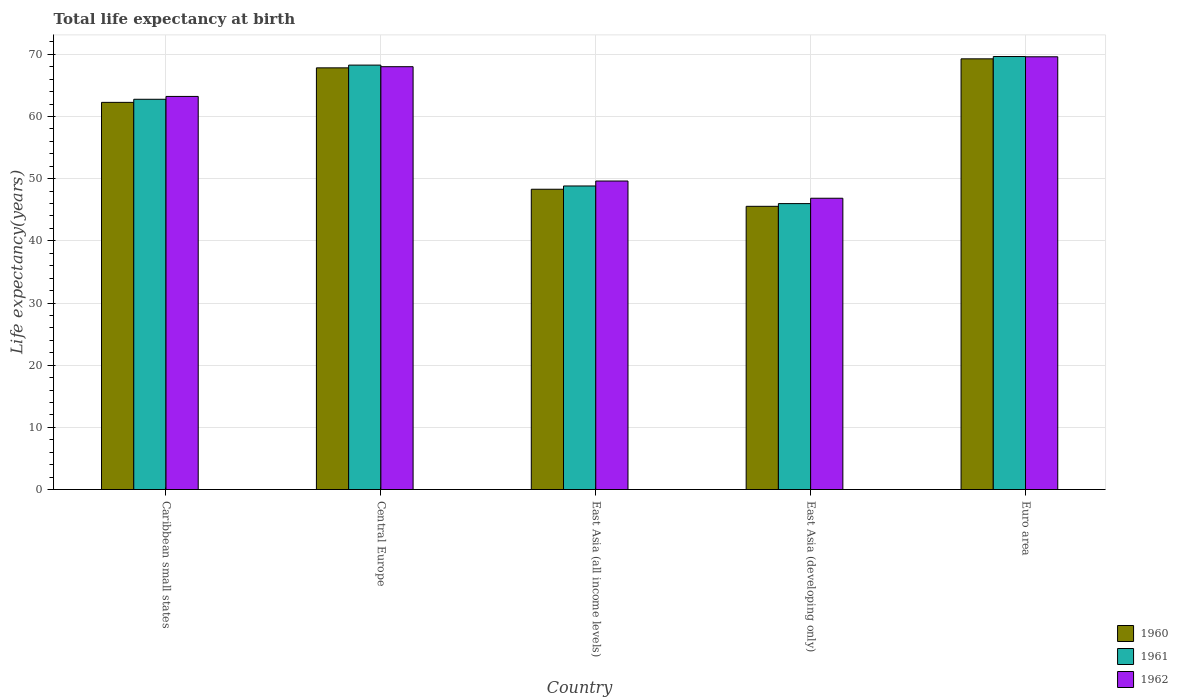Are the number of bars on each tick of the X-axis equal?
Provide a succinct answer. Yes. How many bars are there on the 5th tick from the left?
Offer a terse response. 3. How many bars are there on the 5th tick from the right?
Keep it short and to the point. 3. What is the label of the 3rd group of bars from the left?
Your answer should be compact. East Asia (all income levels). What is the life expectancy at birth in in 1962 in East Asia (developing only)?
Your response must be concise. 46.85. Across all countries, what is the maximum life expectancy at birth in in 1962?
Give a very brief answer. 69.6. Across all countries, what is the minimum life expectancy at birth in in 1960?
Ensure brevity in your answer.  45.55. In which country was the life expectancy at birth in in 1960 minimum?
Make the answer very short. East Asia (developing only). What is the total life expectancy at birth in in 1960 in the graph?
Your response must be concise. 293.22. What is the difference between the life expectancy at birth in in 1962 in East Asia (developing only) and that in Euro area?
Your answer should be compact. -22.75. What is the difference between the life expectancy at birth in in 1961 in Central Europe and the life expectancy at birth in in 1962 in Euro area?
Your answer should be very brief. -1.34. What is the average life expectancy at birth in in 1961 per country?
Provide a succinct answer. 59.1. What is the difference between the life expectancy at birth in of/in 1960 and life expectancy at birth in of/in 1961 in Caribbean small states?
Provide a short and direct response. -0.5. In how many countries, is the life expectancy at birth in in 1961 greater than 4 years?
Keep it short and to the point. 5. What is the ratio of the life expectancy at birth in in 1961 in Caribbean small states to that in Euro area?
Provide a short and direct response. 0.9. Is the life expectancy at birth in in 1960 in Caribbean small states less than that in East Asia (developing only)?
Your response must be concise. No. What is the difference between the highest and the second highest life expectancy at birth in in 1961?
Keep it short and to the point. -1.38. What is the difference between the highest and the lowest life expectancy at birth in in 1962?
Offer a very short reply. 22.75. What does the 3rd bar from the right in East Asia (all income levels) represents?
Your answer should be compact. 1960. Is it the case that in every country, the sum of the life expectancy at birth in in 1961 and life expectancy at birth in in 1960 is greater than the life expectancy at birth in in 1962?
Provide a succinct answer. Yes. How many bars are there?
Provide a short and direct response. 15. Are all the bars in the graph horizontal?
Your answer should be very brief. No. Are the values on the major ticks of Y-axis written in scientific E-notation?
Your answer should be very brief. No. Does the graph contain any zero values?
Offer a terse response. No. Where does the legend appear in the graph?
Provide a succinct answer. Bottom right. How are the legend labels stacked?
Ensure brevity in your answer.  Vertical. What is the title of the graph?
Offer a terse response. Total life expectancy at birth. What is the label or title of the Y-axis?
Ensure brevity in your answer.  Life expectancy(years). What is the Life expectancy(years) in 1960 in Caribbean small states?
Your answer should be compact. 62.27. What is the Life expectancy(years) in 1961 in Caribbean small states?
Offer a very short reply. 62.77. What is the Life expectancy(years) in 1962 in Caribbean small states?
Make the answer very short. 63.23. What is the Life expectancy(years) in 1960 in Central Europe?
Give a very brief answer. 67.82. What is the Life expectancy(years) of 1961 in Central Europe?
Your response must be concise. 68.26. What is the Life expectancy(years) of 1962 in Central Europe?
Provide a short and direct response. 68.01. What is the Life expectancy(years) of 1960 in East Asia (all income levels)?
Give a very brief answer. 48.3. What is the Life expectancy(years) of 1961 in East Asia (all income levels)?
Ensure brevity in your answer.  48.82. What is the Life expectancy(years) in 1962 in East Asia (all income levels)?
Keep it short and to the point. 49.62. What is the Life expectancy(years) of 1960 in East Asia (developing only)?
Give a very brief answer. 45.55. What is the Life expectancy(years) of 1961 in East Asia (developing only)?
Provide a succinct answer. 45.99. What is the Life expectancy(years) of 1962 in East Asia (developing only)?
Give a very brief answer. 46.85. What is the Life expectancy(years) in 1960 in Euro area?
Make the answer very short. 69.27. What is the Life expectancy(years) in 1961 in Euro area?
Offer a terse response. 69.64. What is the Life expectancy(years) of 1962 in Euro area?
Offer a terse response. 69.6. Across all countries, what is the maximum Life expectancy(years) of 1960?
Keep it short and to the point. 69.27. Across all countries, what is the maximum Life expectancy(years) of 1961?
Keep it short and to the point. 69.64. Across all countries, what is the maximum Life expectancy(years) of 1962?
Your answer should be compact. 69.6. Across all countries, what is the minimum Life expectancy(years) in 1960?
Provide a short and direct response. 45.55. Across all countries, what is the minimum Life expectancy(years) in 1961?
Provide a short and direct response. 45.99. Across all countries, what is the minimum Life expectancy(years) in 1962?
Keep it short and to the point. 46.85. What is the total Life expectancy(years) in 1960 in the graph?
Offer a terse response. 293.22. What is the total Life expectancy(years) in 1961 in the graph?
Ensure brevity in your answer.  295.49. What is the total Life expectancy(years) of 1962 in the graph?
Offer a very short reply. 297.31. What is the difference between the Life expectancy(years) of 1960 in Caribbean small states and that in Central Europe?
Your answer should be compact. -5.55. What is the difference between the Life expectancy(years) in 1961 in Caribbean small states and that in Central Europe?
Make the answer very short. -5.49. What is the difference between the Life expectancy(years) in 1962 in Caribbean small states and that in Central Europe?
Offer a very short reply. -4.78. What is the difference between the Life expectancy(years) of 1960 in Caribbean small states and that in East Asia (all income levels)?
Your response must be concise. 13.97. What is the difference between the Life expectancy(years) of 1961 in Caribbean small states and that in East Asia (all income levels)?
Give a very brief answer. 13.95. What is the difference between the Life expectancy(years) of 1962 in Caribbean small states and that in East Asia (all income levels)?
Give a very brief answer. 13.61. What is the difference between the Life expectancy(years) of 1960 in Caribbean small states and that in East Asia (developing only)?
Your answer should be compact. 16.72. What is the difference between the Life expectancy(years) in 1961 in Caribbean small states and that in East Asia (developing only)?
Your response must be concise. 16.78. What is the difference between the Life expectancy(years) of 1962 in Caribbean small states and that in East Asia (developing only)?
Your answer should be compact. 16.37. What is the difference between the Life expectancy(years) of 1960 in Caribbean small states and that in Euro area?
Make the answer very short. -7. What is the difference between the Life expectancy(years) in 1961 in Caribbean small states and that in Euro area?
Keep it short and to the point. -6.88. What is the difference between the Life expectancy(years) of 1962 in Caribbean small states and that in Euro area?
Your answer should be very brief. -6.38. What is the difference between the Life expectancy(years) of 1960 in Central Europe and that in East Asia (all income levels)?
Your answer should be compact. 19.53. What is the difference between the Life expectancy(years) in 1961 in Central Europe and that in East Asia (all income levels)?
Offer a very short reply. 19.44. What is the difference between the Life expectancy(years) in 1962 in Central Europe and that in East Asia (all income levels)?
Offer a terse response. 18.39. What is the difference between the Life expectancy(years) of 1960 in Central Europe and that in East Asia (developing only)?
Your response must be concise. 22.27. What is the difference between the Life expectancy(years) of 1961 in Central Europe and that in East Asia (developing only)?
Offer a very short reply. 22.28. What is the difference between the Life expectancy(years) in 1962 in Central Europe and that in East Asia (developing only)?
Offer a very short reply. 21.16. What is the difference between the Life expectancy(years) of 1960 in Central Europe and that in Euro area?
Provide a short and direct response. -1.45. What is the difference between the Life expectancy(years) in 1961 in Central Europe and that in Euro area?
Ensure brevity in your answer.  -1.38. What is the difference between the Life expectancy(years) of 1962 in Central Europe and that in Euro area?
Offer a very short reply. -1.59. What is the difference between the Life expectancy(years) of 1960 in East Asia (all income levels) and that in East Asia (developing only)?
Provide a succinct answer. 2.75. What is the difference between the Life expectancy(years) of 1961 in East Asia (all income levels) and that in East Asia (developing only)?
Make the answer very short. 2.84. What is the difference between the Life expectancy(years) of 1962 in East Asia (all income levels) and that in East Asia (developing only)?
Provide a succinct answer. 2.77. What is the difference between the Life expectancy(years) in 1960 in East Asia (all income levels) and that in Euro area?
Your answer should be compact. -20.98. What is the difference between the Life expectancy(years) in 1961 in East Asia (all income levels) and that in Euro area?
Keep it short and to the point. -20.82. What is the difference between the Life expectancy(years) in 1962 in East Asia (all income levels) and that in Euro area?
Your response must be concise. -19.98. What is the difference between the Life expectancy(years) in 1960 in East Asia (developing only) and that in Euro area?
Make the answer very short. -23.72. What is the difference between the Life expectancy(years) in 1961 in East Asia (developing only) and that in Euro area?
Provide a succinct answer. -23.66. What is the difference between the Life expectancy(years) in 1962 in East Asia (developing only) and that in Euro area?
Provide a succinct answer. -22.75. What is the difference between the Life expectancy(years) in 1960 in Caribbean small states and the Life expectancy(years) in 1961 in Central Europe?
Provide a succinct answer. -5.99. What is the difference between the Life expectancy(years) of 1960 in Caribbean small states and the Life expectancy(years) of 1962 in Central Europe?
Provide a short and direct response. -5.74. What is the difference between the Life expectancy(years) of 1961 in Caribbean small states and the Life expectancy(years) of 1962 in Central Europe?
Keep it short and to the point. -5.24. What is the difference between the Life expectancy(years) in 1960 in Caribbean small states and the Life expectancy(years) in 1961 in East Asia (all income levels)?
Your answer should be compact. 13.45. What is the difference between the Life expectancy(years) in 1960 in Caribbean small states and the Life expectancy(years) in 1962 in East Asia (all income levels)?
Provide a succinct answer. 12.65. What is the difference between the Life expectancy(years) in 1961 in Caribbean small states and the Life expectancy(years) in 1962 in East Asia (all income levels)?
Give a very brief answer. 13.15. What is the difference between the Life expectancy(years) in 1960 in Caribbean small states and the Life expectancy(years) in 1961 in East Asia (developing only)?
Keep it short and to the point. 16.28. What is the difference between the Life expectancy(years) of 1960 in Caribbean small states and the Life expectancy(years) of 1962 in East Asia (developing only)?
Offer a very short reply. 15.42. What is the difference between the Life expectancy(years) of 1961 in Caribbean small states and the Life expectancy(years) of 1962 in East Asia (developing only)?
Offer a very short reply. 15.92. What is the difference between the Life expectancy(years) in 1960 in Caribbean small states and the Life expectancy(years) in 1961 in Euro area?
Your answer should be very brief. -7.37. What is the difference between the Life expectancy(years) in 1960 in Caribbean small states and the Life expectancy(years) in 1962 in Euro area?
Make the answer very short. -7.33. What is the difference between the Life expectancy(years) of 1961 in Caribbean small states and the Life expectancy(years) of 1962 in Euro area?
Your response must be concise. -6.83. What is the difference between the Life expectancy(years) of 1960 in Central Europe and the Life expectancy(years) of 1961 in East Asia (all income levels)?
Provide a short and direct response. 19. What is the difference between the Life expectancy(years) of 1960 in Central Europe and the Life expectancy(years) of 1962 in East Asia (all income levels)?
Provide a succinct answer. 18.2. What is the difference between the Life expectancy(years) of 1961 in Central Europe and the Life expectancy(years) of 1962 in East Asia (all income levels)?
Provide a succinct answer. 18.64. What is the difference between the Life expectancy(years) in 1960 in Central Europe and the Life expectancy(years) in 1961 in East Asia (developing only)?
Ensure brevity in your answer.  21.84. What is the difference between the Life expectancy(years) in 1960 in Central Europe and the Life expectancy(years) in 1962 in East Asia (developing only)?
Offer a terse response. 20.97. What is the difference between the Life expectancy(years) of 1961 in Central Europe and the Life expectancy(years) of 1962 in East Asia (developing only)?
Ensure brevity in your answer.  21.41. What is the difference between the Life expectancy(years) of 1960 in Central Europe and the Life expectancy(years) of 1961 in Euro area?
Keep it short and to the point. -1.82. What is the difference between the Life expectancy(years) of 1960 in Central Europe and the Life expectancy(years) of 1962 in Euro area?
Ensure brevity in your answer.  -1.78. What is the difference between the Life expectancy(years) in 1961 in Central Europe and the Life expectancy(years) in 1962 in Euro area?
Your response must be concise. -1.34. What is the difference between the Life expectancy(years) of 1960 in East Asia (all income levels) and the Life expectancy(years) of 1961 in East Asia (developing only)?
Provide a succinct answer. 2.31. What is the difference between the Life expectancy(years) in 1960 in East Asia (all income levels) and the Life expectancy(years) in 1962 in East Asia (developing only)?
Your response must be concise. 1.45. What is the difference between the Life expectancy(years) of 1961 in East Asia (all income levels) and the Life expectancy(years) of 1962 in East Asia (developing only)?
Make the answer very short. 1.97. What is the difference between the Life expectancy(years) of 1960 in East Asia (all income levels) and the Life expectancy(years) of 1961 in Euro area?
Your answer should be compact. -21.35. What is the difference between the Life expectancy(years) of 1960 in East Asia (all income levels) and the Life expectancy(years) of 1962 in Euro area?
Make the answer very short. -21.3. What is the difference between the Life expectancy(years) in 1961 in East Asia (all income levels) and the Life expectancy(years) in 1962 in Euro area?
Offer a very short reply. -20.78. What is the difference between the Life expectancy(years) in 1960 in East Asia (developing only) and the Life expectancy(years) in 1961 in Euro area?
Keep it short and to the point. -24.09. What is the difference between the Life expectancy(years) in 1960 in East Asia (developing only) and the Life expectancy(years) in 1962 in Euro area?
Give a very brief answer. -24.05. What is the difference between the Life expectancy(years) of 1961 in East Asia (developing only) and the Life expectancy(years) of 1962 in Euro area?
Ensure brevity in your answer.  -23.62. What is the average Life expectancy(years) of 1960 per country?
Provide a short and direct response. 58.64. What is the average Life expectancy(years) of 1961 per country?
Keep it short and to the point. 59.1. What is the average Life expectancy(years) in 1962 per country?
Give a very brief answer. 59.46. What is the difference between the Life expectancy(years) in 1960 and Life expectancy(years) in 1961 in Caribbean small states?
Offer a terse response. -0.5. What is the difference between the Life expectancy(years) of 1960 and Life expectancy(years) of 1962 in Caribbean small states?
Your response must be concise. -0.95. What is the difference between the Life expectancy(years) of 1961 and Life expectancy(years) of 1962 in Caribbean small states?
Provide a short and direct response. -0.46. What is the difference between the Life expectancy(years) of 1960 and Life expectancy(years) of 1961 in Central Europe?
Provide a short and direct response. -0.44. What is the difference between the Life expectancy(years) of 1960 and Life expectancy(years) of 1962 in Central Europe?
Provide a succinct answer. -0.18. What is the difference between the Life expectancy(years) of 1961 and Life expectancy(years) of 1962 in Central Europe?
Offer a terse response. 0.26. What is the difference between the Life expectancy(years) of 1960 and Life expectancy(years) of 1961 in East Asia (all income levels)?
Keep it short and to the point. -0.53. What is the difference between the Life expectancy(years) in 1960 and Life expectancy(years) in 1962 in East Asia (all income levels)?
Ensure brevity in your answer.  -1.32. What is the difference between the Life expectancy(years) in 1961 and Life expectancy(years) in 1962 in East Asia (all income levels)?
Provide a short and direct response. -0.8. What is the difference between the Life expectancy(years) of 1960 and Life expectancy(years) of 1961 in East Asia (developing only)?
Your answer should be very brief. -0.44. What is the difference between the Life expectancy(years) in 1960 and Life expectancy(years) in 1962 in East Asia (developing only)?
Offer a very short reply. -1.3. What is the difference between the Life expectancy(years) of 1961 and Life expectancy(years) of 1962 in East Asia (developing only)?
Ensure brevity in your answer.  -0.86. What is the difference between the Life expectancy(years) in 1960 and Life expectancy(years) in 1961 in Euro area?
Offer a terse response. -0.37. What is the difference between the Life expectancy(years) of 1960 and Life expectancy(years) of 1962 in Euro area?
Offer a very short reply. -0.33. What is the difference between the Life expectancy(years) in 1961 and Life expectancy(years) in 1962 in Euro area?
Ensure brevity in your answer.  0.04. What is the ratio of the Life expectancy(years) in 1960 in Caribbean small states to that in Central Europe?
Ensure brevity in your answer.  0.92. What is the ratio of the Life expectancy(years) of 1961 in Caribbean small states to that in Central Europe?
Provide a short and direct response. 0.92. What is the ratio of the Life expectancy(years) of 1962 in Caribbean small states to that in Central Europe?
Offer a very short reply. 0.93. What is the ratio of the Life expectancy(years) of 1960 in Caribbean small states to that in East Asia (all income levels)?
Provide a succinct answer. 1.29. What is the ratio of the Life expectancy(years) in 1961 in Caribbean small states to that in East Asia (all income levels)?
Offer a very short reply. 1.29. What is the ratio of the Life expectancy(years) in 1962 in Caribbean small states to that in East Asia (all income levels)?
Keep it short and to the point. 1.27. What is the ratio of the Life expectancy(years) in 1960 in Caribbean small states to that in East Asia (developing only)?
Provide a succinct answer. 1.37. What is the ratio of the Life expectancy(years) of 1961 in Caribbean small states to that in East Asia (developing only)?
Provide a short and direct response. 1.36. What is the ratio of the Life expectancy(years) in 1962 in Caribbean small states to that in East Asia (developing only)?
Provide a succinct answer. 1.35. What is the ratio of the Life expectancy(years) of 1960 in Caribbean small states to that in Euro area?
Make the answer very short. 0.9. What is the ratio of the Life expectancy(years) of 1961 in Caribbean small states to that in Euro area?
Ensure brevity in your answer.  0.9. What is the ratio of the Life expectancy(years) of 1962 in Caribbean small states to that in Euro area?
Make the answer very short. 0.91. What is the ratio of the Life expectancy(years) of 1960 in Central Europe to that in East Asia (all income levels)?
Offer a very short reply. 1.4. What is the ratio of the Life expectancy(years) of 1961 in Central Europe to that in East Asia (all income levels)?
Your answer should be very brief. 1.4. What is the ratio of the Life expectancy(years) in 1962 in Central Europe to that in East Asia (all income levels)?
Offer a terse response. 1.37. What is the ratio of the Life expectancy(years) in 1960 in Central Europe to that in East Asia (developing only)?
Provide a short and direct response. 1.49. What is the ratio of the Life expectancy(years) in 1961 in Central Europe to that in East Asia (developing only)?
Give a very brief answer. 1.48. What is the ratio of the Life expectancy(years) in 1962 in Central Europe to that in East Asia (developing only)?
Keep it short and to the point. 1.45. What is the ratio of the Life expectancy(years) in 1960 in Central Europe to that in Euro area?
Ensure brevity in your answer.  0.98. What is the ratio of the Life expectancy(years) of 1961 in Central Europe to that in Euro area?
Provide a succinct answer. 0.98. What is the ratio of the Life expectancy(years) in 1962 in Central Europe to that in Euro area?
Provide a succinct answer. 0.98. What is the ratio of the Life expectancy(years) of 1960 in East Asia (all income levels) to that in East Asia (developing only)?
Provide a succinct answer. 1.06. What is the ratio of the Life expectancy(years) in 1961 in East Asia (all income levels) to that in East Asia (developing only)?
Offer a terse response. 1.06. What is the ratio of the Life expectancy(years) of 1962 in East Asia (all income levels) to that in East Asia (developing only)?
Provide a succinct answer. 1.06. What is the ratio of the Life expectancy(years) of 1960 in East Asia (all income levels) to that in Euro area?
Provide a succinct answer. 0.7. What is the ratio of the Life expectancy(years) of 1961 in East Asia (all income levels) to that in Euro area?
Provide a short and direct response. 0.7. What is the ratio of the Life expectancy(years) of 1962 in East Asia (all income levels) to that in Euro area?
Give a very brief answer. 0.71. What is the ratio of the Life expectancy(years) of 1960 in East Asia (developing only) to that in Euro area?
Your answer should be very brief. 0.66. What is the ratio of the Life expectancy(years) in 1961 in East Asia (developing only) to that in Euro area?
Provide a succinct answer. 0.66. What is the ratio of the Life expectancy(years) in 1962 in East Asia (developing only) to that in Euro area?
Keep it short and to the point. 0.67. What is the difference between the highest and the second highest Life expectancy(years) of 1960?
Offer a very short reply. 1.45. What is the difference between the highest and the second highest Life expectancy(years) in 1961?
Your response must be concise. 1.38. What is the difference between the highest and the second highest Life expectancy(years) of 1962?
Offer a terse response. 1.59. What is the difference between the highest and the lowest Life expectancy(years) of 1960?
Make the answer very short. 23.72. What is the difference between the highest and the lowest Life expectancy(years) in 1961?
Keep it short and to the point. 23.66. What is the difference between the highest and the lowest Life expectancy(years) in 1962?
Offer a very short reply. 22.75. 